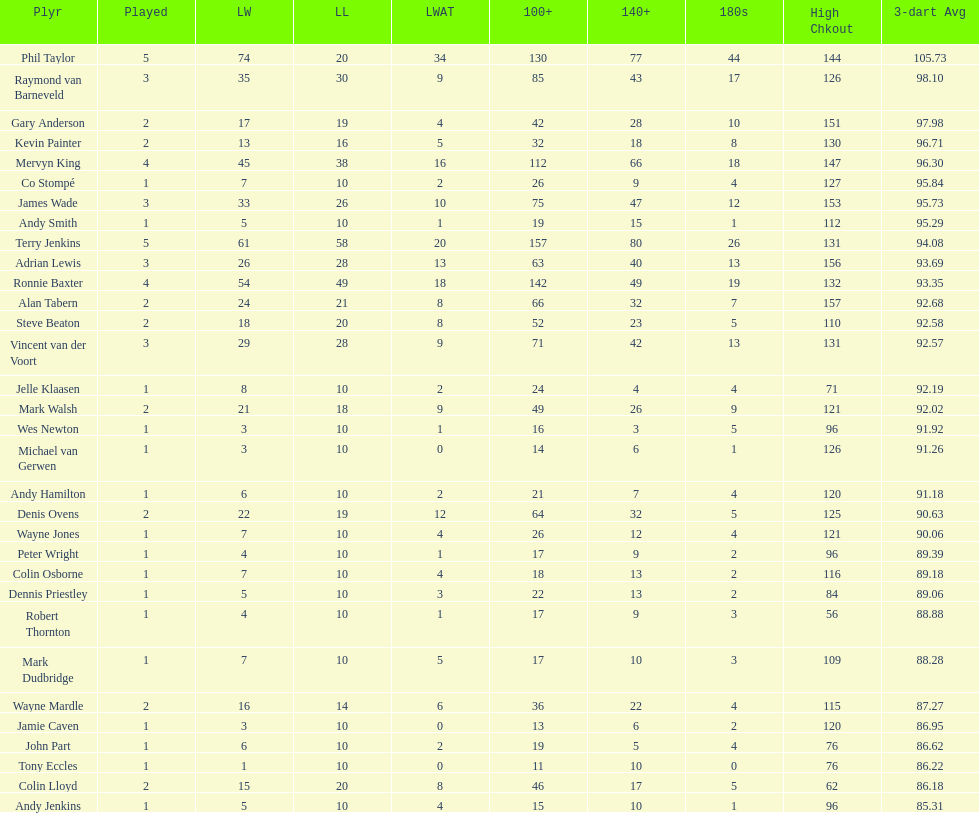Would you be able to parse every entry in this table? {'header': ['Plyr', 'Played', 'LW', 'LL', 'LWAT', '100+', '140+', '180s', 'High Chkout', '3-dart Avg'], 'rows': [['Phil Taylor', '5', '74', '20', '34', '130', '77', '44', '144', '105.73'], ['Raymond van Barneveld', '3', '35', '30', '9', '85', '43', '17', '126', '98.10'], ['Gary Anderson', '2', '17', '19', '4', '42', '28', '10', '151', '97.98'], ['Kevin Painter', '2', '13', '16', '5', '32', '18', '8', '130', '96.71'], ['Mervyn King', '4', '45', '38', '16', '112', '66', '18', '147', '96.30'], ['Co Stompé', '1', '7', '10', '2', '26', '9', '4', '127', '95.84'], ['James Wade', '3', '33', '26', '10', '75', '47', '12', '153', '95.73'], ['Andy Smith', '1', '5', '10', '1', '19', '15', '1', '112', '95.29'], ['Terry Jenkins', '5', '61', '58', '20', '157', '80', '26', '131', '94.08'], ['Adrian Lewis', '3', '26', '28', '13', '63', '40', '13', '156', '93.69'], ['Ronnie Baxter', '4', '54', '49', '18', '142', '49', '19', '132', '93.35'], ['Alan Tabern', '2', '24', '21', '8', '66', '32', '7', '157', '92.68'], ['Steve Beaton', '2', '18', '20', '8', '52', '23', '5', '110', '92.58'], ['Vincent van der Voort', '3', '29', '28', '9', '71', '42', '13', '131', '92.57'], ['Jelle Klaasen', '1', '8', '10', '2', '24', '4', '4', '71', '92.19'], ['Mark Walsh', '2', '21', '18', '9', '49', '26', '9', '121', '92.02'], ['Wes Newton', '1', '3', '10', '1', '16', '3', '5', '96', '91.92'], ['Michael van Gerwen', '1', '3', '10', '0', '14', '6', '1', '126', '91.26'], ['Andy Hamilton', '1', '6', '10', '2', '21', '7', '4', '120', '91.18'], ['Denis Ovens', '2', '22', '19', '12', '64', '32', '5', '125', '90.63'], ['Wayne Jones', '1', '7', '10', '4', '26', '12', '4', '121', '90.06'], ['Peter Wright', '1', '4', '10', '1', '17', '9', '2', '96', '89.39'], ['Colin Osborne', '1', '7', '10', '4', '18', '13', '2', '116', '89.18'], ['Dennis Priestley', '1', '5', '10', '3', '22', '13', '2', '84', '89.06'], ['Robert Thornton', '1', '4', '10', '1', '17', '9', '3', '56', '88.88'], ['Mark Dudbridge', '1', '7', '10', '5', '17', '10', '3', '109', '88.28'], ['Wayne Mardle', '2', '16', '14', '6', '36', '22', '4', '115', '87.27'], ['Jamie Caven', '1', '3', '10', '0', '13', '6', '2', '120', '86.95'], ['John Part', '1', '6', '10', '2', '19', '5', '4', '76', '86.62'], ['Tony Eccles', '1', '1', '10', '0', '11', '10', '0', '76', '86.22'], ['Colin Lloyd', '2', '15', '20', '8', '46', '17', '5', '62', '86.18'], ['Andy Jenkins', '1', '5', '10', '4', '15', '10', '1', '96', '85.31']]} Who won the highest number of legs in the 2009 world matchplay? Phil Taylor. 